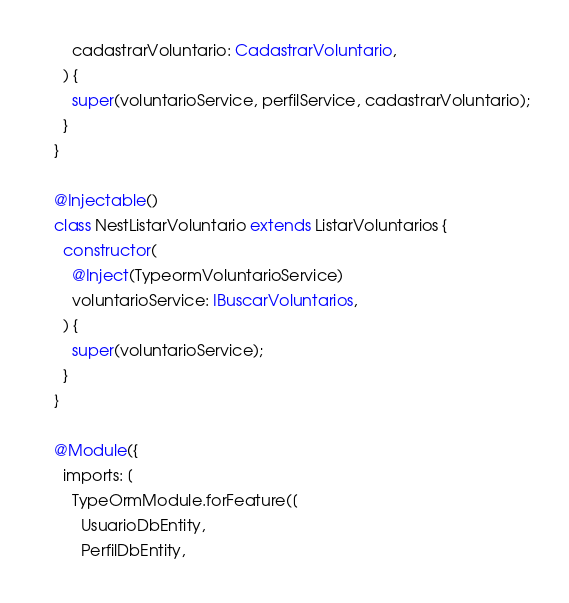<code> <loc_0><loc_0><loc_500><loc_500><_TypeScript_>    cadastrarVoluntario: CadastrarVoluntario,
  ) {
    super(voluntarioService, perfilService, cadastrarVoluntario);
  }
}

@Injectable()
class NestListarVoluntario extends ListarVoluntarios {
  constructor(
    @Inject(TypeormVoluntarioService)
    voluntarioService: IBuscarVoluntarios,
  ) {
    super(voluntarioService);
  }
}

@Module({
  imports: [
    TypeOrmModule.forFeature([
      UsuarioDbEntity,
      PerfilDbEntity,</code> 